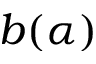<formula> <loc_0><loc_0><loc_500><loc_500>b ( \alpha )</formula> 